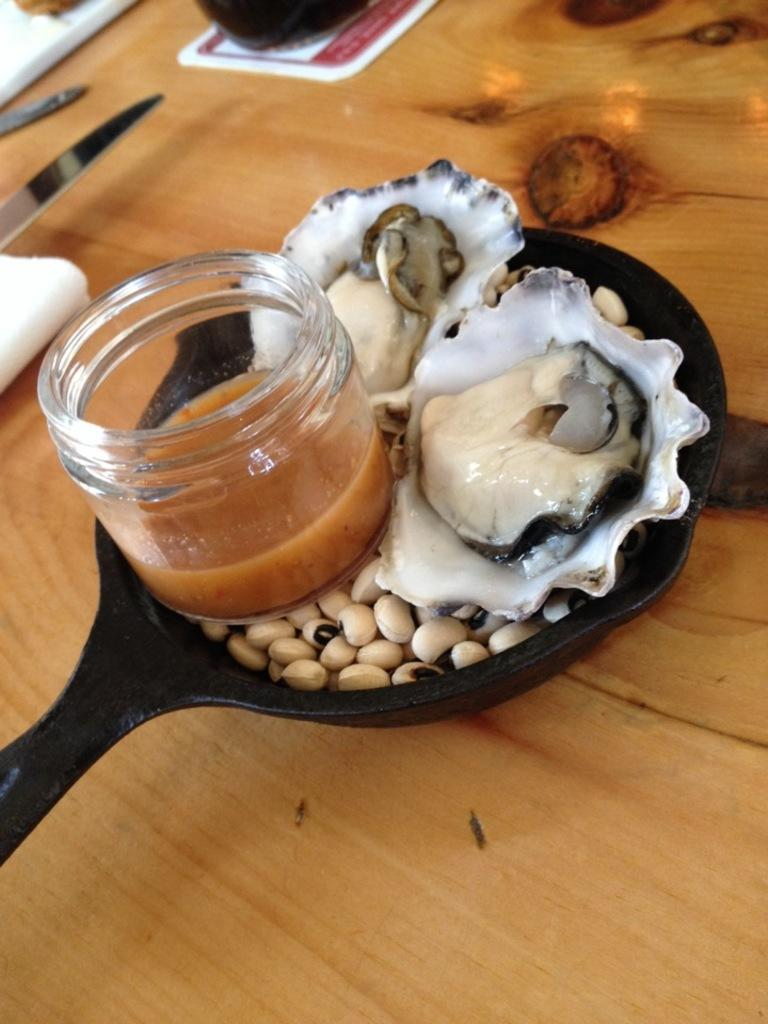What is being cooked in the pan in the image? The facts do not specify the type of food item in the pan, but there is a food item in a pan in the image. What is in the glass item in the image? There is a liquid in a glass item in the image. What utensil is present in the image? There is a knife in the image. What other objects can be seen on the table in the image? The facts do not specify the other objects on the table, but there are other objects on the table in the image. How fast does the son run in the image? There is no son or running depicted in the image; it only shows a food item in a pan, a liquid in a glass item, a knife, and other objects on a table. 